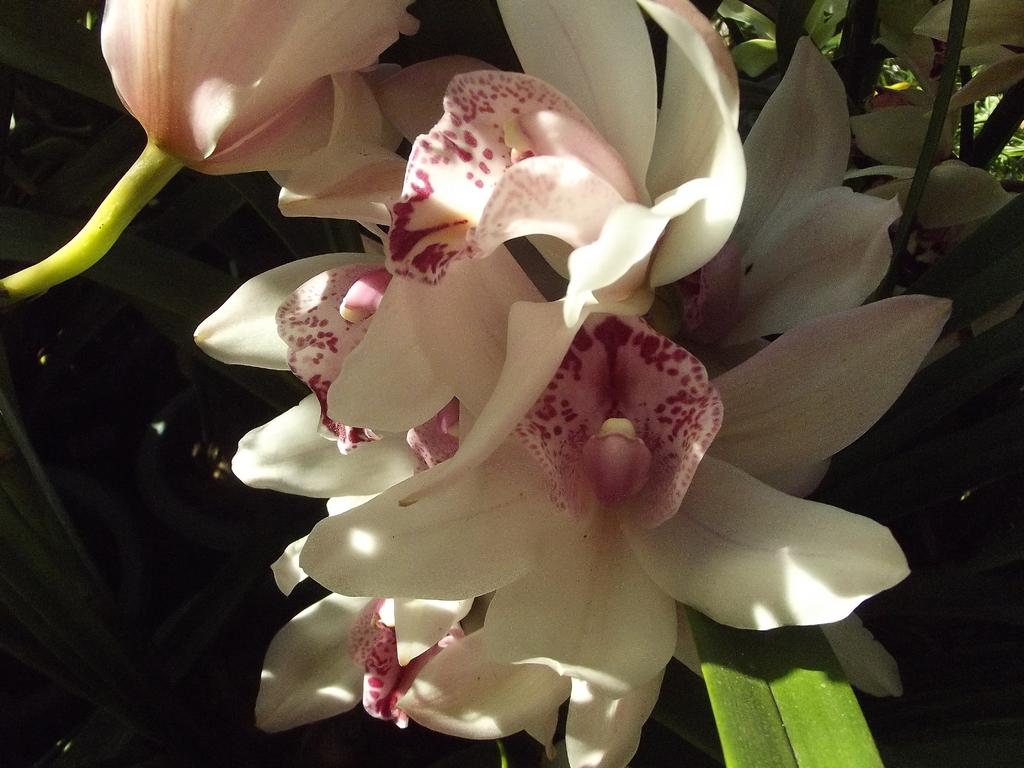What is the main subject in the center of the image? There are flowers in the center of the image. What is the flowers attached to? The flowers are on a plant. What else can be seen around the flowers in the image? There are leaves around the area of the image. What type of experience can be gained from the leaf in the image? There is no experience to be gained from the leaf in the image, as it is a static object and not an activity or event. 